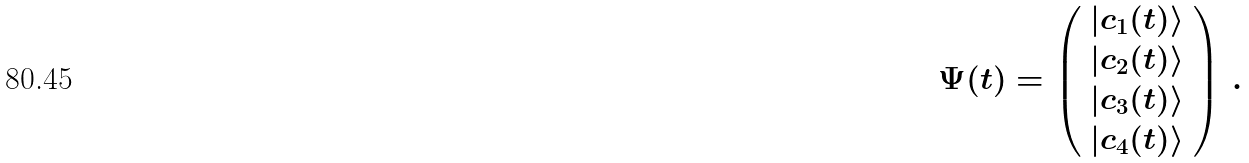Convert formula to latex. <formula><loc_0><loc_0><loc_500><loc_500>\Psi ( t ) = \left ( \begin{array} { c } | c _ { 1 } ( t ) \rangle \\ | c _ { 2 } ( t ) \rangle \\ | c _ { 3 } ( t ) \rangle \\ | c _ { 4 } ( t ) \rangle \end{array} \right ) \, .</formula> 